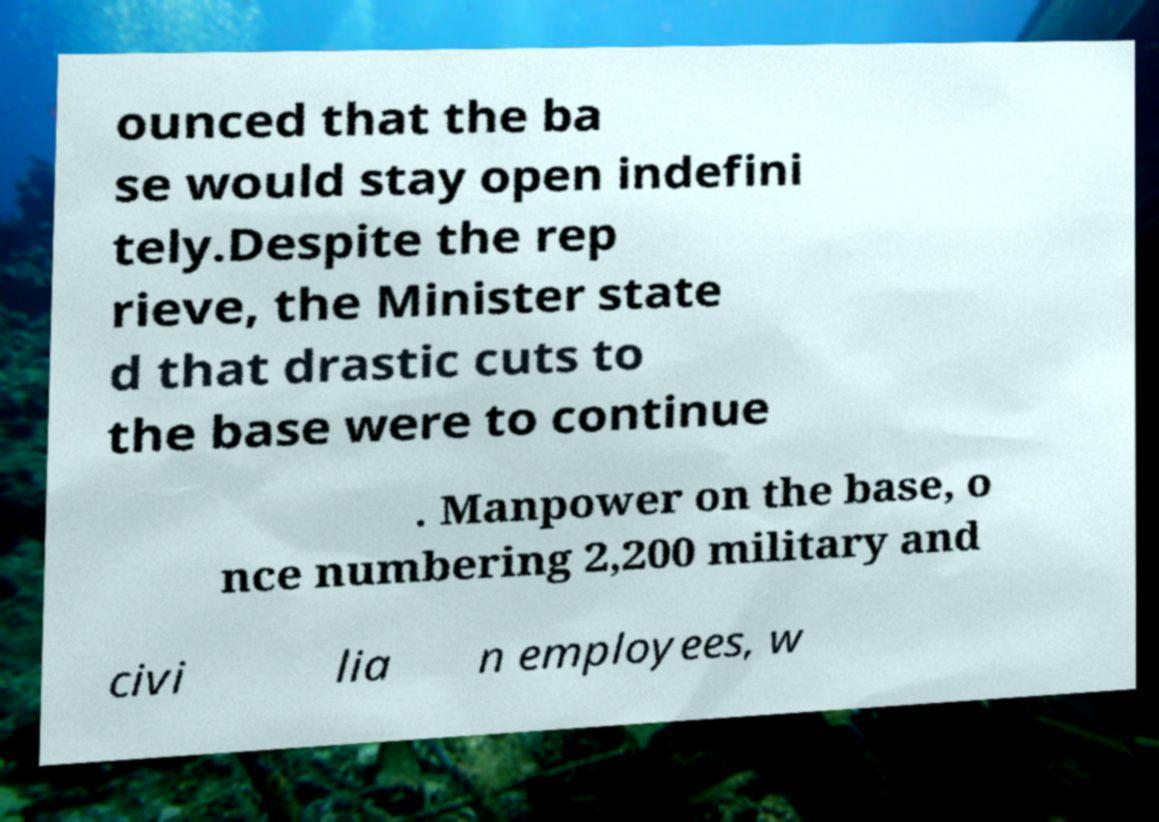Can you read and provide the text displayed in the image?This photo seems to have some interesting text. Can you extract and type it out for me? ounced that the ba se would stay open indefini tely.Despite the rep rieve, the Minister state d that drastic cuts to the base were to continue . Manpower on the base, o nce numbering 2,200 military and civi lia n employees, w 